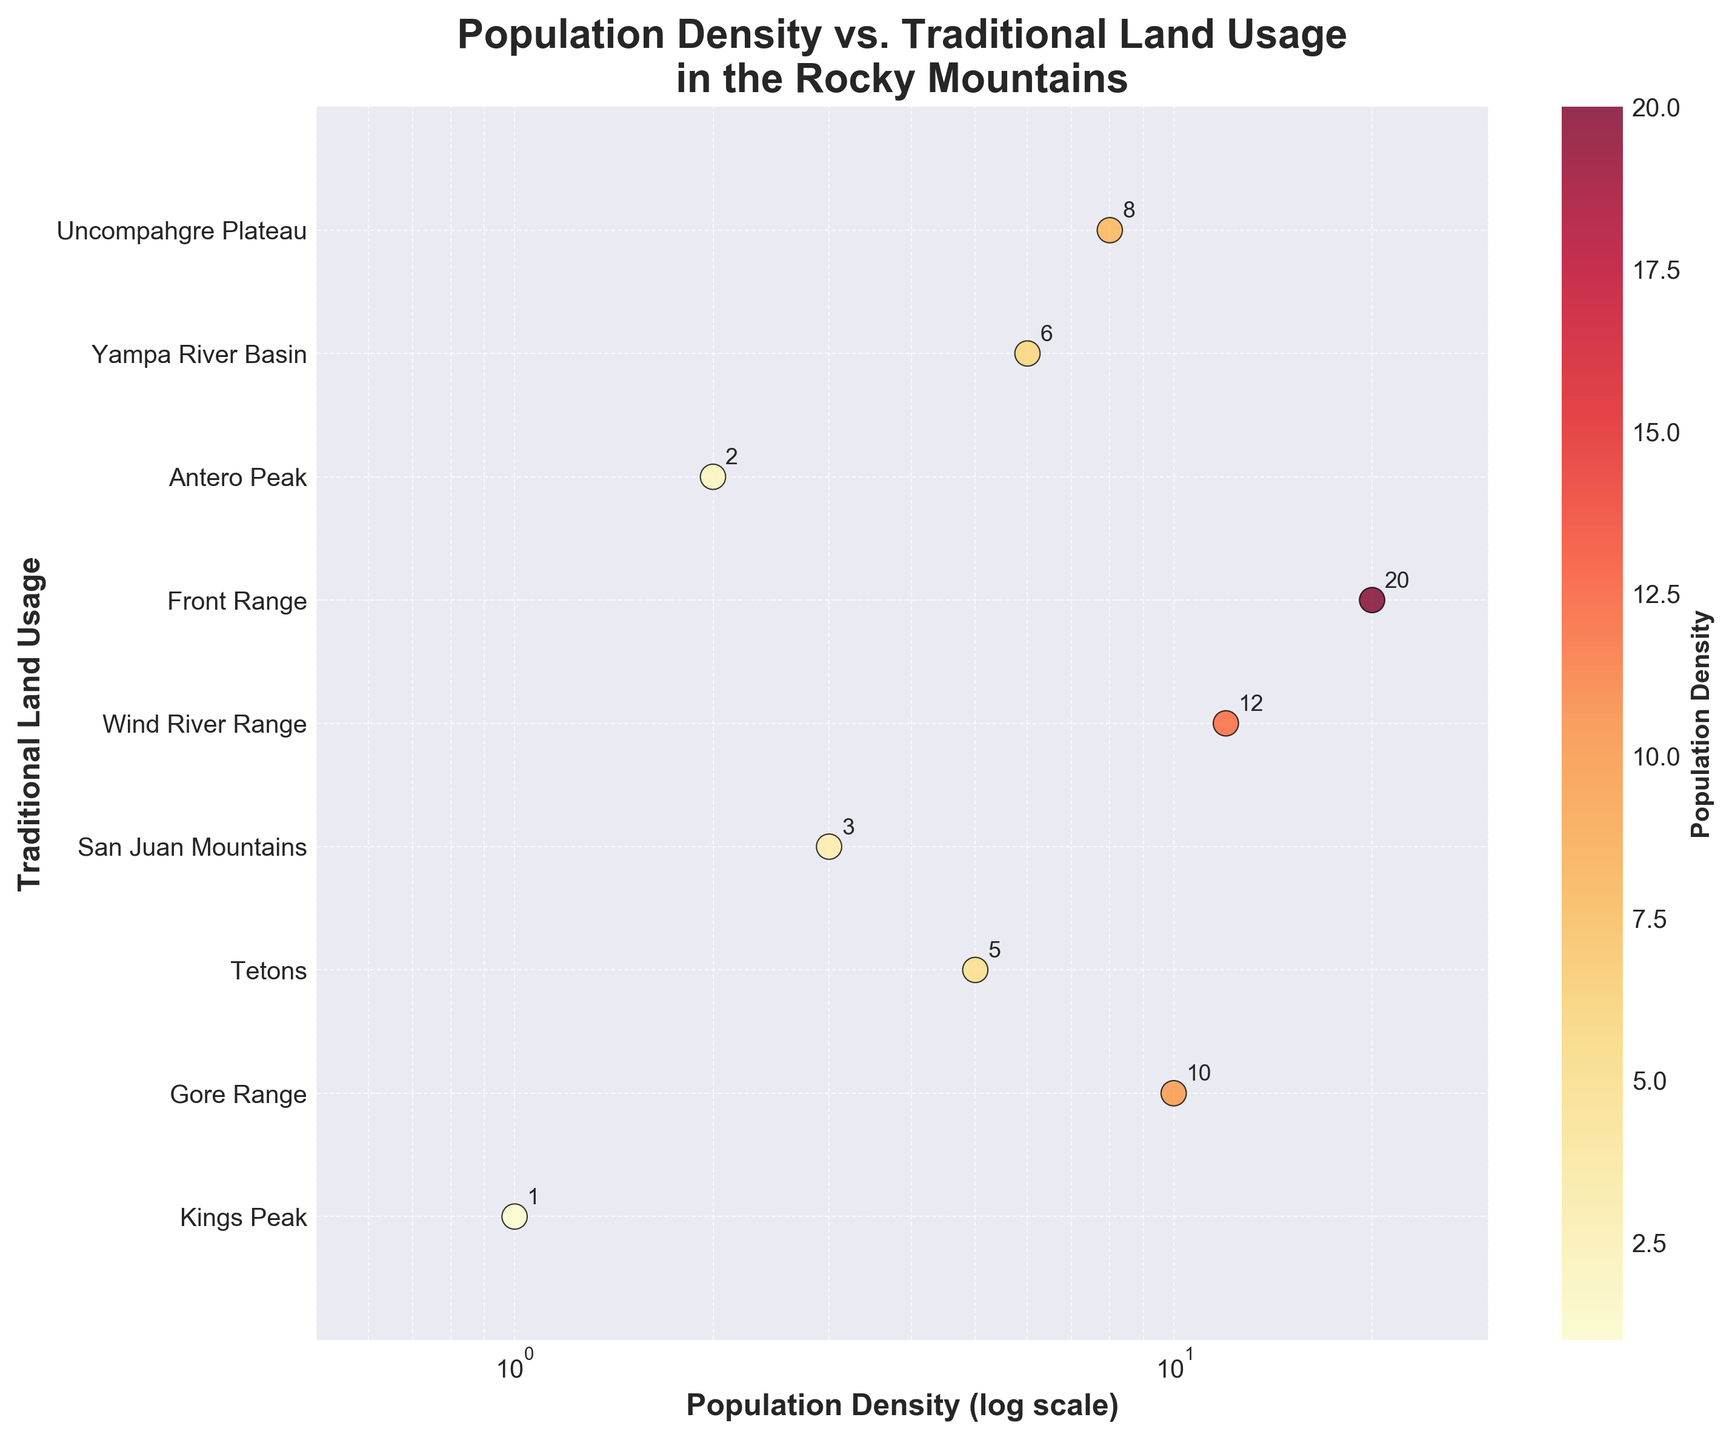What is the title of the figure? The title of the figure is prominently displayed at the top and reads "Population Density vs. Traditional Land Usage in the Rocky Mountains".
Answer: Population Density vs. Traditional Land Usage in the Rocky Mountains Which traditional land usage area has the highest population density? The Front Range has the highest population density, as it is the data point furthest to the right on the X-axis.
Answer: Front Range How many traditional land usage areas are depicted in the figure? Counting each unique label on the Y-axis shows there are 9 traditional land usage areas depicted in the figure.
Answer: 9 Which areas have population densities below 5? The areas with population densities below 5 are Kings Peak, San Juan Mountains, and Antero Peak. This is determined by observing data points at population densities 1, 3, and 2 respectively.
Answer: Kings Peak, San Juan Mountains, Antero Peak What’s the average population density of all the areas? To find the average population density, sum all the densities (1+10+5+3+12+20+2+6+8 = 67) and divide by the number of areas (9). Thus, average = 67/9.
Answer: 7.44 Which area is positioned exactly between two other areas in terms of population density? The Tetons have a population density of 5, which lies between the density of San Juan Mountains (3) and Yampa River Basin (6), making it centrally positioned among these specific data points.
Answer: Tetons Which traditional land usage areas have population densities greater than 10? The areas with population densities greater than 10 are Wind River Range and Front Range, corresponding to densities 12 and 20 respectively.
Answer: Wind River Range, Front Range What does the color gradient in the scatter plot indicate? The color gradient on the scatter plot indicates the population density, with different shades representing varying density levels. Darker shades typically indicate higher densities.
Answer: Population density Compare the population densities of Yampa River Basin and Uncompahgre Plateau. Which is higher? Looking at their positions on the X-axis, Yampa River Basin has a population density of 6 and Uncompahgre Plateau has 8, meaning Uncompahgre Plateau has a higher density.
Answer: Uncompahgre Plateau What is the population density of Kings Peak as indicated on the plot? By looking at the annotated values directly on the scatter plot for Kings Peak, the population density is seen as 1.
Answer: 1 